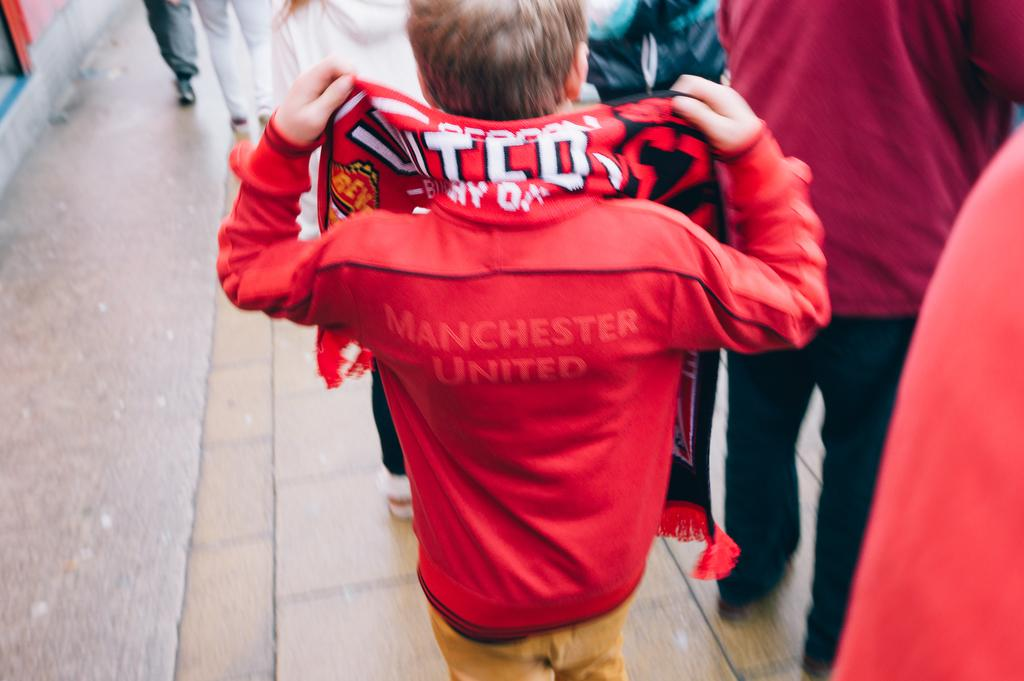<image>
Summarize the visual content of the image. A boy sports a bright red jacket with the words MANCHESTER UNITED barely visible on it. 